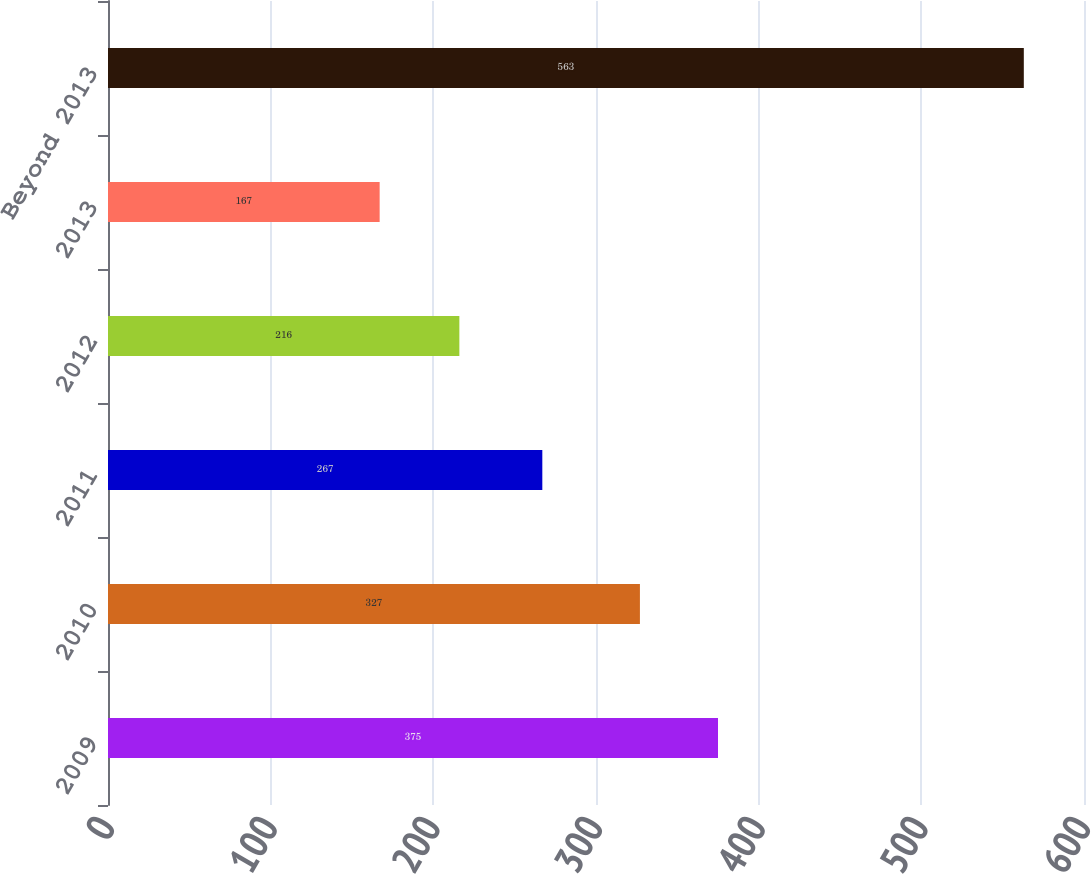<chart> <loc_0><loc_0><loc_500><loc_500><bar_chart><fcel>2009<fcel>2010<fcel>2011<fcel>2012<fcel>2013<fcel>Beyond 2013<nl><fcel>375<fcel>327<fcel>267<fcel>216<fcel>167<fcel>563<nl></chart> 